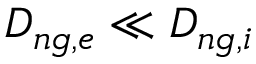<formula> <loc_0><loc_0><loc_500><loc_500>D _ { n g , e } \ll D _ { n g , i }</formula> 